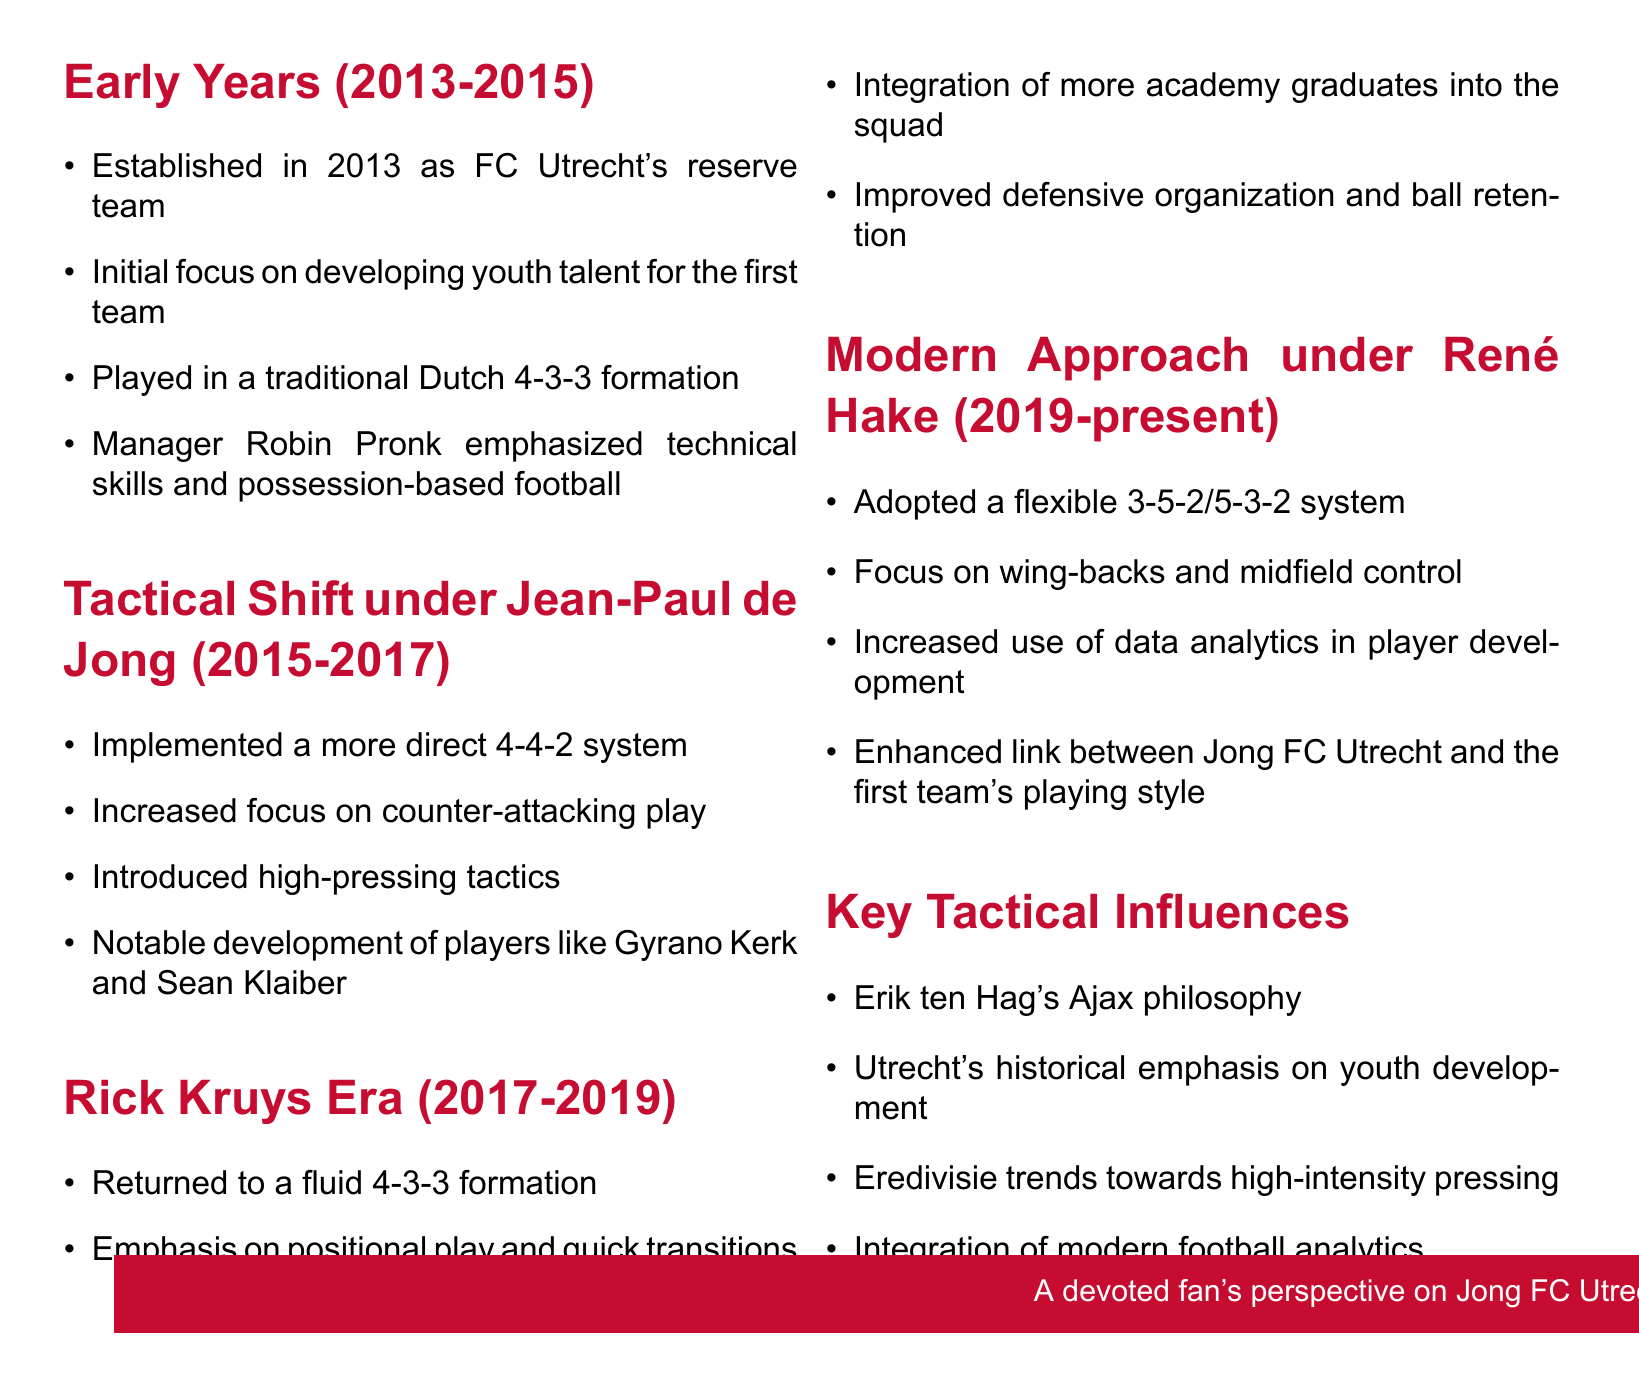What formation did Jong FC Utrecht initially use from 2013-2015? The document states they played in a traditional Dutch 4-3-3 formation during their early years.
Answer: 4-3-3 Who was the manager during the tactical shift from 2015-2017? The notes mention Jean-Paul de Jong as the manager in this period.
Answer: Jean-Paul de Jong What tactical system was introduced in the Rick Kruys Era? The document indicates a return to a fluid 4-3-3 formation during Rick Kruys' management.
Answer: 4-3-3 What is the current tactical system used under René Hake since 2019? The notes describe the adoption of a flexible 3-5-2/5-3-2 system under René Hake.
Answer: 3-5-2/5-3-2 Which two players were notably developed under Jean-Paul de Jong? The document lists Gyrano Kerk and Sean Klaiber as notable developments during his era.
Answer: Gyrano Kerk and Sean Klaiber How did Jong FC Utrecht's focus change under René Hake? The document highlights an increased use of data analytics in player development under Hake.
Answer: Data analytics What historical philosophy has influenced Jong FC Utrecht's tactical approach? The notes mention Erik ten Hag's Ajax philosophy as a key influence.
Answer: Erik ten Hag's Ajax philosophy What was emphasized during the early years of Jong FC Utrecht? The document states the initial focus was on developing youth talent for the first team.
Answer: Youth talent development How long did Rick Kruys manage Jong FC Utrecht? According to the document, Rick Kruys managed Jong FC Utrecht from 2017 to 2019, a span of two years.
Answer: Two years 